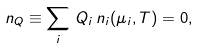<formula> <loc_0><loc_0><loc_500><loc_500>n _ { Q } \equiv \sum _ { i } \, Q _ { i } \, n _ { i } ( \mu _ { i } , T ) = 0 ,</formula> 